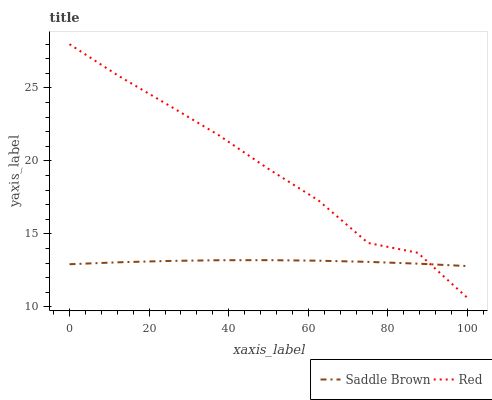Does Saddle Brown have the minimum area under the curve?
Answer yes or no. Yes. Does Red have the maximum area under the curve?
Answer yes or no. Yes. Does Red have the minimum area under the curve?
Answer yes or no. No. Is Saddle Brown the smoothest?
Answer yes or no. Yes. Is Red the roughest?
Answer yes or no. Yes. Is Red the smoothest?
Answer yes or no. No. Does Red have the lowest value?
Answer yes or no. Yes. Does Red have the highest value?
Answer yes or no. Yes. Does Saddle Brown intersect Red?
Answer yes or no. Yes. Is Saddle Brown less than Red?
Answer yes or no. No. Is Saddle Brown greater than Red?
Answer yes or no. No. 